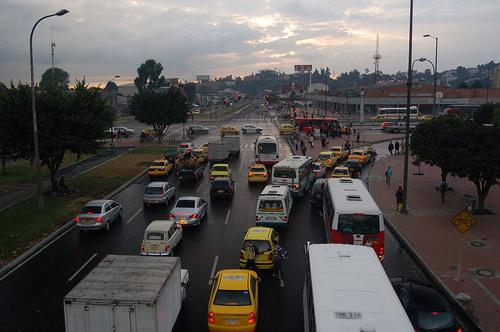What picture is on the sign that is all the way to the right?

Choices:
A) baby
B) cabbage
C) horse
D) bicycle bicycle 